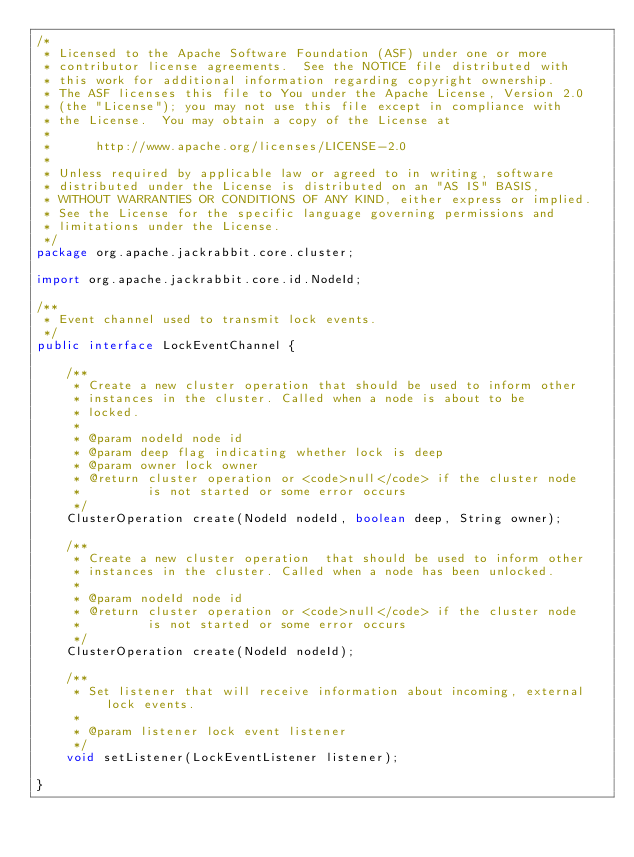<code> <loc_0><loc_0><loc_500><loc_500><_Java_>/*
 * Licensed to the Apache Software Foundation (ASF) under one or more
 * contributor license agreements.  See the NOTICE file distributed with
 * this work for additional information regarding copyright ownership.
 * The ASF licenses this file to You under the Apache License, Version 2.0
 * (the "License"); you may not use this file except in compliance with
 * the License.  You may obtain a copy of the License at
 *
 *      http://www.apache.org/licenses/LICENSE-2.0
 *
 * Unless required by applicable law or agreed to in writing, software
 * distributed under the License is distributed on an "AS IS" BASIS,
 * WITHOUT WARRANTIES OR CONDITIONS OF ANY KIND, either express or implied.
 * See the License for the specific language governing permissions and
 * limitations under the License.
 */
package org.apache.jackrabbit.core.cluster;

import org.apache.jackrabbit.core.id.NodeId;

/**
 * Event channel used to transmit lock events.
 */
public interface LockEventChannel {

    /**
     * Create a new cluster operation that should be used to inform other
     * instances in the cluster. Called when a node is about to be
     * locked.
     *
     * @param nodeId node id
     * @param deep flag indicating whether lock is deep
     * @param owner lock owner
     * @return cluster operation or <code>null</code> if the cluster node
     *         is not started or some error occurs
     */
    ClusterOperation create(NodeId nodeId, boolean deep, String owner);

    /**
     * Create a new cluster operation  that should be used to inform other
     * instances in the cluster. Called when a node has been unlocked.
     *
     * @param nodeId node id
     * @return cluster operation or <code>null</code> if the cluster node
     *         is not started or some error occurs
     */
    ClusterOperation create(NodeId nodeId);

    /**
     * Set listener that will receive information about incoming, external lock events.
     *
     * @param listener lock event listener
     */
    void setListener(LockEventListener listener);

}
</code> 